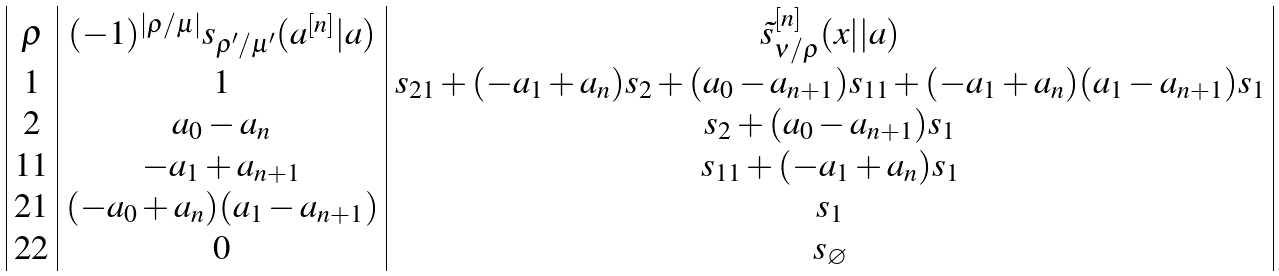Convert formula to latex. <formula><loc_0><loc_0><loc_500><loc_500>\begin{array} { | c | c | c | } \rho & ( - 1 ) ^ { | \rho / \mu | } s _ { \rho ^ { \prime } / \mu ^ { \prime } } ( a ^ { [ n ] } | a ) & \tilde { s } ^ { [ n ] } _ { \nu / \rho } ( x | | a ) \\ 1 & 1 & s _ { 2 1 } + ( - a _ { 1 } + a _ { n } ) s _ { 2 } + ( a _ { 0 } - a _ { n + 1 } ) s _ { 1 1 } + ( - a _ { 1 } + a _ { n } ) ( a _ { 1 } - a _ { n + 1 } ) s _ { 1 } \\ 2 & a _ { 0 } - a _ { n } & s _ { 2 } + ( a _ { 0 } - a _ { n + 1 } ) s _ { 1 } \\ 1 1 & - a _ { 1 } + a _ { n + 1 } & s _ { 1 1 } + ( - a _ { 1 } + a _ { n } ) s _ { 1 } \\ 2 1 & ( - a _ { 0 } + a _ { n } ) ( a _ { 1 } - a _ { n + 1 } ) & s _ { 1 } \\ 2 2 & 0 & s _ { \varnothing } \\ \end{array}</formula> 